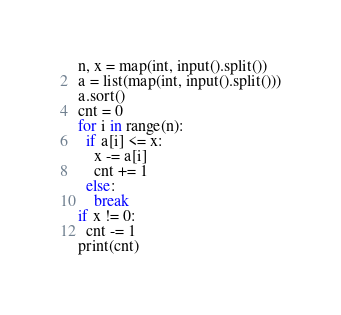Convert code to text. <code><loc_0><loc_0><loc_500><loc_500><_Python_>n, x = map(int, input().split())
a = list(map(int, input().split()))
a.sort()
cnt = 0
for i in range(n):
  if a[i] <= x:
    x -= a[i]
    cnt += 1
  else:
    break
if x != 0:
  cnt -= 1
print(cnt)</code> 